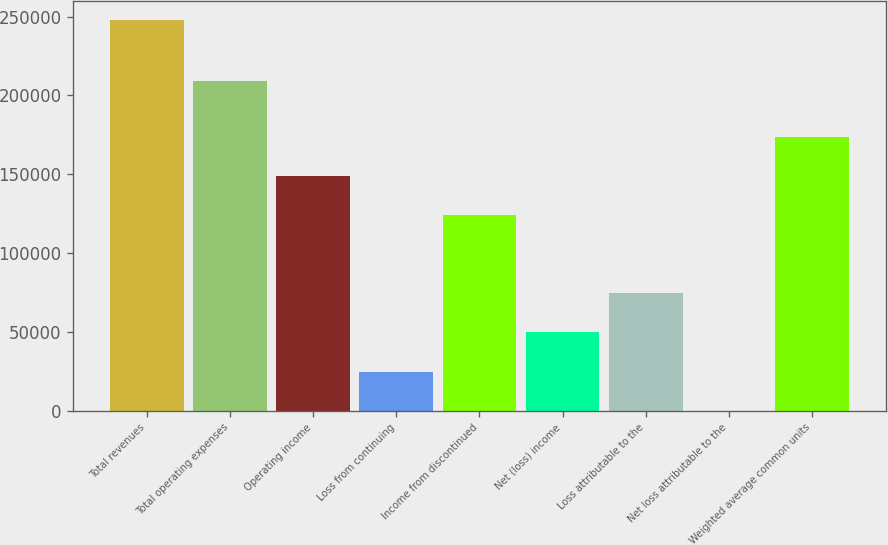<chart> <loc_0><loc_0><loc_500><loc_500><bar_chart><fcel>Total revenues<fcel>Total operating expenses<fcel>Operating income<fcel>Loss from continuing<fcel>Income from discontinued<fcel>Net (loss) income<fcel>Loss attributable to the<fcel>Net loss attributable to the<fcel>Weighted average common units<nl><fcel>247838<fcel>208884<fcel>148703<fcel>24783.9<fcel>123919<fcel>49567.7<fcel>74351.5<fcel>0.12<fcel>173487<nl></chart> 